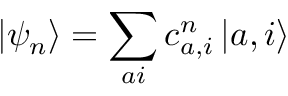<formula> <loc_0><loc_0><loc_500><loc_500>\left | \psi _ { n } \right \rangle = \sum _ { a i } c _ { a , i } ^ { n } \left | a , i \right \rangle</formula> 